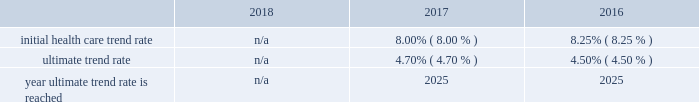Marathon oil corporation notes to consolidated financial statements expected long-term return on plan assets 2013 the expected long-term return on plan assets assumption for our u.s .
Funded plan is determined based on an asset rate-of-return modeling tool developed by a third-party investment group which utilizes underlying assumptions based on actual returns by asset category and inflation and takes into account our u.s .
Pension plan 2019s asset allocation .
To determine the expected long-term return on plan assets assumption for our international plans , we consider the current level of expected returns on risk-free investments ( primarily government bonds ) , the historical levels of the risk premiums associated with the other applicable asset categories and the expectations for future returns of each asset class .
The expected return for each asset category is then weighted based on the actual asset allocation to develop the overall expected long-term return on plan assets assumption .
Assumed weighted average health care cost trend rates .
N/a all retiree medical subsidies are frozen as of january 1 , 2019 .
Employer provided subsidies for post-65 retiree health care coverage were frozen effective january 1 , 2017 at january 1 , 2016 established amount levels .
Company contributions are funded to a health reimbursement account on the retiree 2019s behalf to subsidize the retiree 2019s cost of obtaining health care benefits through a private exchange ( the 201cpost-65 retiree health benefits 201d ) .
Therefore , a 1% ( 1 % ) change in health care cost trend rates would not have a material impact on either the service and interest cost components and the postretirement benefit obligations .
In the fourth quarter of 2018 , we terminated the post-65 retiree health benefits effective as of december 31 , 2020 .
The post-65 retiree health benefits will no longer be provided after that date .
In addition , the pre-65 retiree medical coverage subsidy has been frozen as of january 1 , 2019 , and the ability for retirees to opt in and out of this coverage , as well as pre-65 retiree dental and vision coverage , has also been eliminated .
Retirees must enroll in connection with retirement for such coverage , or they lose eligibility .
These plan changes reduced our retiree medical benefit obligation by approximately $ 99 million .
Plan investment policies and strategies 2013 the investment policies for our u.s .
And international pension plan assets reflect the funded status of the plans and expectations regarding our future ability to make further contributions .
Long-term investment goals are to : ( 1 ) manage the assets in accordance with applicable legal requirements ; ( 2 ) produce investment returns which meet or exceed the rates of return achievable in the capital markets while maintaining the risk parameters set by the plan's investment committees and protecting the assets from any erosion of purchasing power ; and ( 3 ) position the portfolios with a long-term risk/ return orientation .
Investment performance and risk is measured and monitored on an ongoing basis through quarterly investment meetings and periodic asset and liability studies .
U.s .
Plan 2013 the plan 2019s current targeted asset allocation is comprised of 55% ( 55 % ) equity securities and 45% ( 45 % ) other fixed income securities .
Over time , as the plan 2019s funded ratio ( as defined by the investment policy ) improves , in order to reduce volatility in returns and to better match the plan 2019s liabilities , the allocation to equity securities will decrease while the amount allocated to fixed income securities will increase .
The plan's assets are managed by a third-party investment manager .
International plan 2013 our international plan's target asset allocation is comprised of 55% ( 55 % ) equity securities and 45% ( 45 % ) fixed income securities .
The plan assets are invested in ten separate portfolios , mainly pooled fund vehicles , managed by several professional investment managers whose performance is measured independently by a third-party asset servicing consulting fair value measurements 2013 plan assets are measured at fair value .
The following provides a description of the valuation techniques employed for each major plan asset class at december 31 , 2018 and 2017 .
Cash and cash equivalents 2013 cash and cash equivalents are valued using a market approach and are considered level 1 .
Equity securities 2013 investments in common stock are valued using a market approach at the closing price reported in an active market and are therefore considered level 1 .
Private equity investments include interests in limited partnerships which are valued based on the sum of the estimated fair values of the investments held by each partnership , determined using a combination of market , income and cost approaches , plus working capital , adjusted for liabilities , currency translation and estimated performance incentives .
These private equity investments are considered level 3 .
Investments in pooled funds are valued using a market approach , these various funds consist of equity with underlying investments held in u.s .
And non-u.s .
Securities .
The pooled funds are benchmarked against a relative public index and are considered level 2. .
What was the difference in the initial health care trend rate and the ultimate trend rate in 2016? 
Computations: (8.25% - 4.50%)
Answer: 0.0375. 